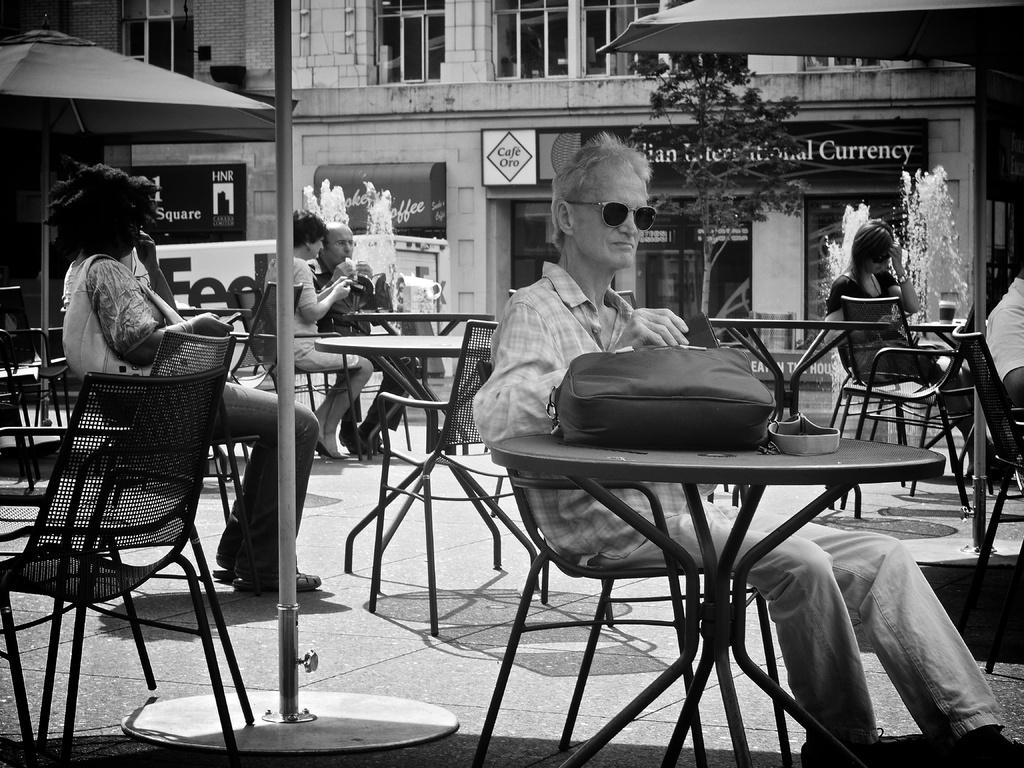What type of furniture is present in the image? There are chairs and tables in the image. What are the people in the image doing? The people are sitting on chairs at the tables. What can be seen in the background of the image? There is a building, trees, tents, a fountain, a hoarding, and a pole in the background of the image. How many cars are parked near the fountain in the image? There are no cars present in the image; it only features chairs, tables, people, and the mentioned background elements. Is there a gun visible in the hands of any person in the image? There is no gun present in the image; no one is holding or using any weapon. 